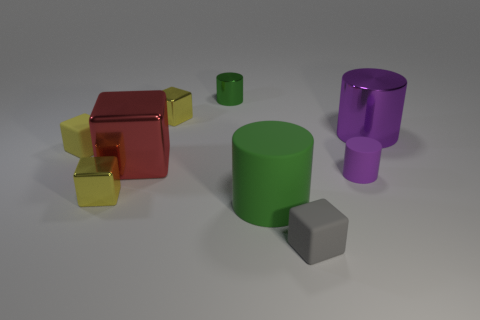Does this arrangement of objects suggest any particular use or purpose? The arrangement of objects doesn't suggest a conventional use or purpose; it appears to be a random assortment of geometric shapes, possibly for the purpose of visual demonstration or as part of a 3D rendering test to exhibit material and lighting effects. Could there be an educational purpose behind this assortment? Absolutely, this collection of objects could serve as a practical visual aid for educational purposes, such as teaching about shapes, colors, geometry, or the principles of light and materials in computer graphics. 